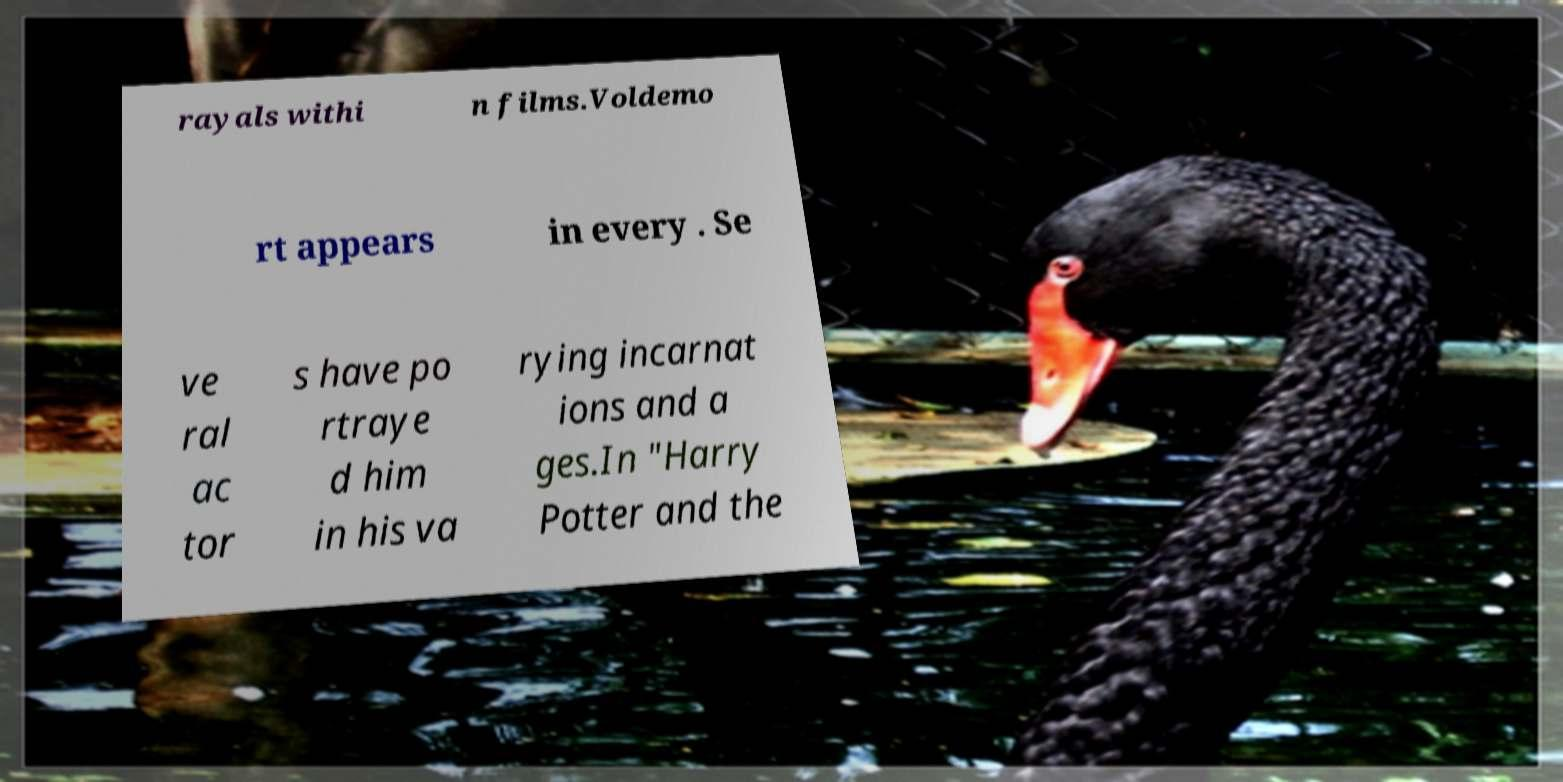Could you extract and type out the text from this image? rayals withi n films.Voldemo rt appears in every . Se ve ral ac tor s have po rtraye d him in his va rying incarnat ions and a ges.In "Harry Potter and the 